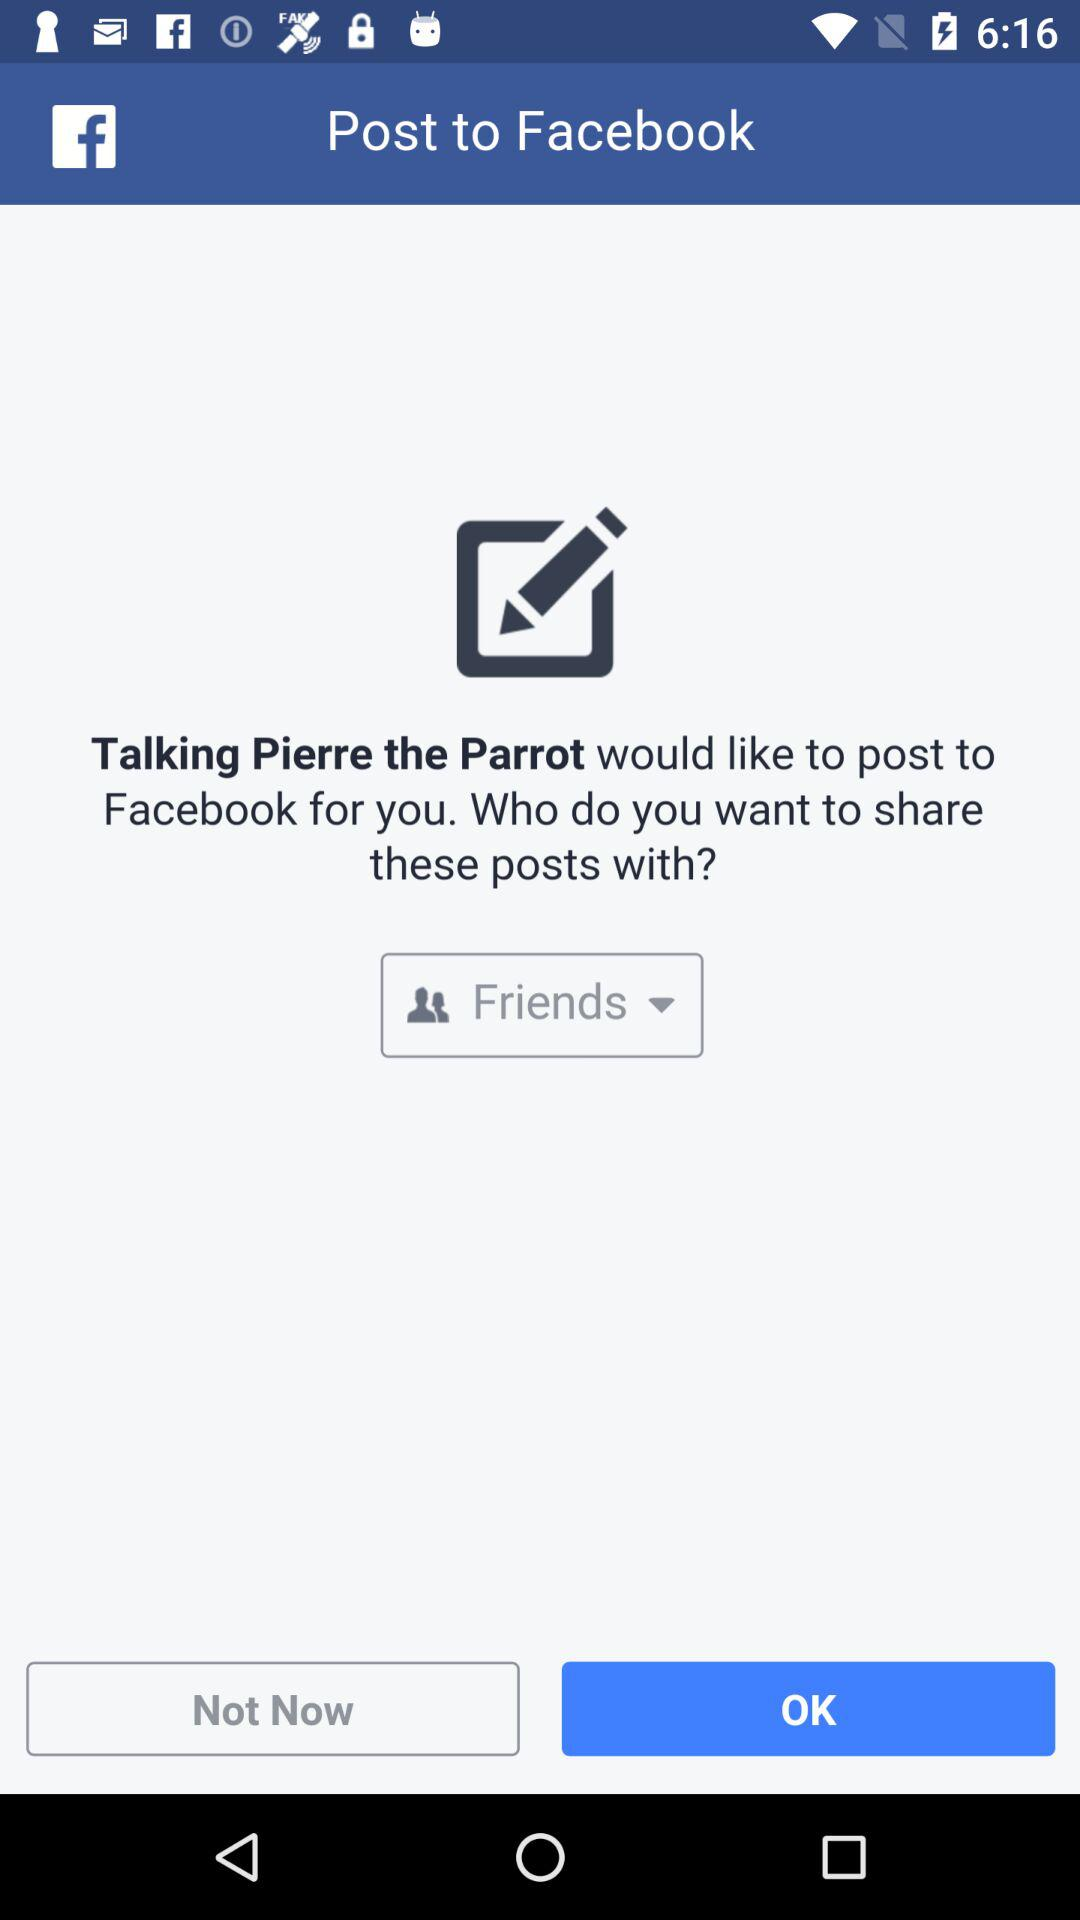What application would like to post to "Facebook"? The application "Talking Pierre the Parrot" would like to post to Facebook. 